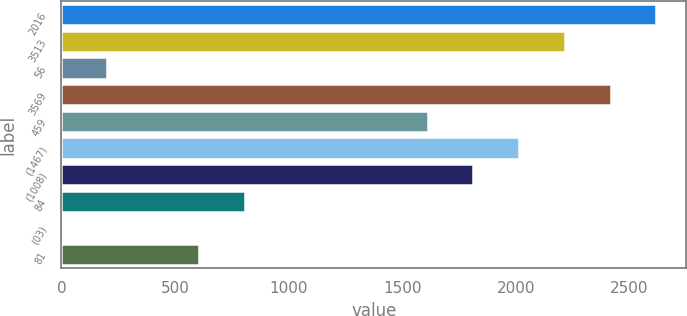Convert chart. <chart><loc_0><loc_0><loc_500><loc_500><bar_chart><fcel>2016<fcel>3513<fcel>56<fcel>3569<fcel>459<fcel>(1467)<fcel>(1008)<fcel>84<fcel>(03)<fcel>81<nl><fcel>2617.87<fcel>2215.29<fcel>202.39<fcel>2416.58<fcel>1611.42<fcel>2014<fcel>1812.71<fcel>806.26<fcel>1.1<fcel>604.97<nl></chart> 